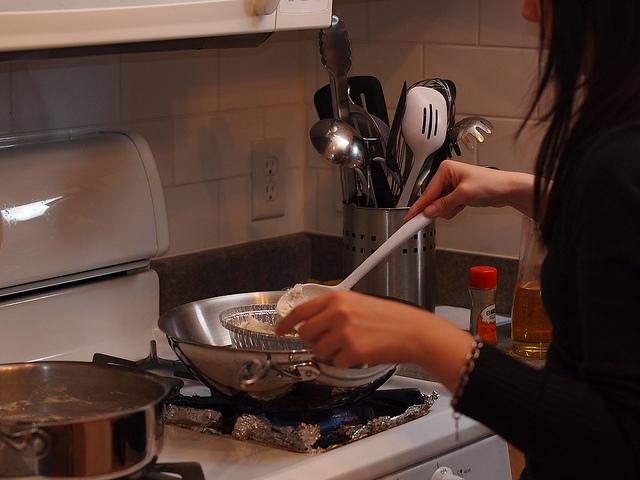How does this woman keep her stovetop clean?
Concise answer only. Foil. What color is the ladle?
Be succinct. White. What room is this?
Quick response, please. Kitchen. 